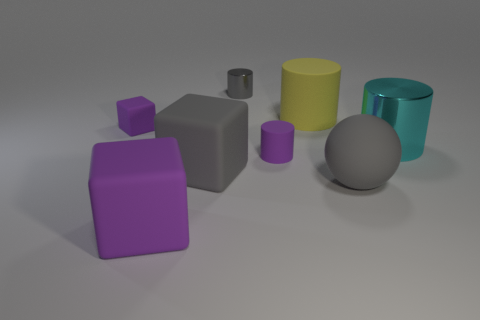Subtract all big blocks. How many blocks are left? 1 Add 1 small rubber blocks. How many objects exist? 9 Subtract all purple blocks. How many blocks are left? 1 Subtract 1 gray balls. How many objects are left? 7 Subtract all blocks. How many objects are left? 5 Subtract 2 cylinders. How many cylinders are left? 2 Subtract all green cylinders. Subtract all red cubes. How many cylinders are left? 4 Subtract all cyan cylinders. How many blue blocks are left? 0 Subtract all small rubber cubes. Subtract all tiny gray cylinders. How many objects are left? 6 Add 3 spheres. How many spheres are left? 4 